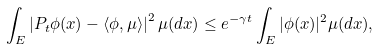<formula> <loc_0><loc_0><loc_500><loc_500>\int _ { E } \left | P _ { t } \phi ( x ) - \left \langle \phi , \mu \right \rangle \right | ^ { 2 } \mu ( d x ) \leq e ^ { - \gamma t } \int _ { E } | \phi ( x ) | ^ { 2 } \mu ( d x ) ,</formula> 